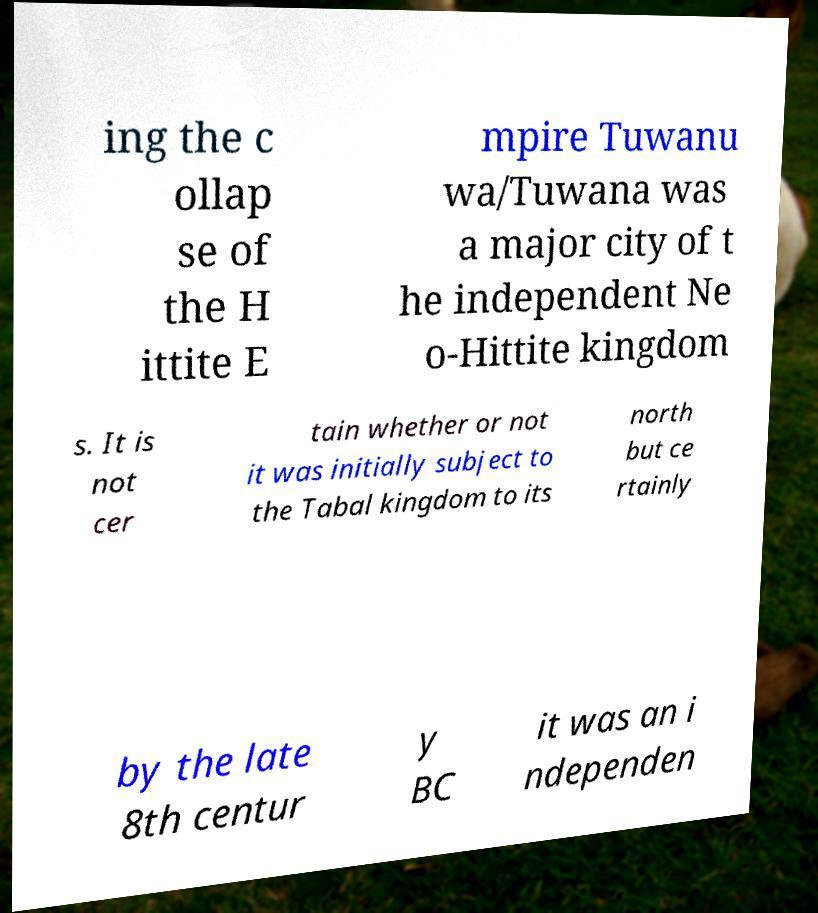Can you accurately transcribe the text from the provided image for me? ing the c ollap se of the H ittite E mpire Tuwanu wa/Tuwana was a major city of t he independent Ne o-Hittite kingdom s. It is not cer tain whether or not it was initially subject to the Tabal kingdom to its north but ce rtainly by the late 8th centur y BC it was an i ndependen 